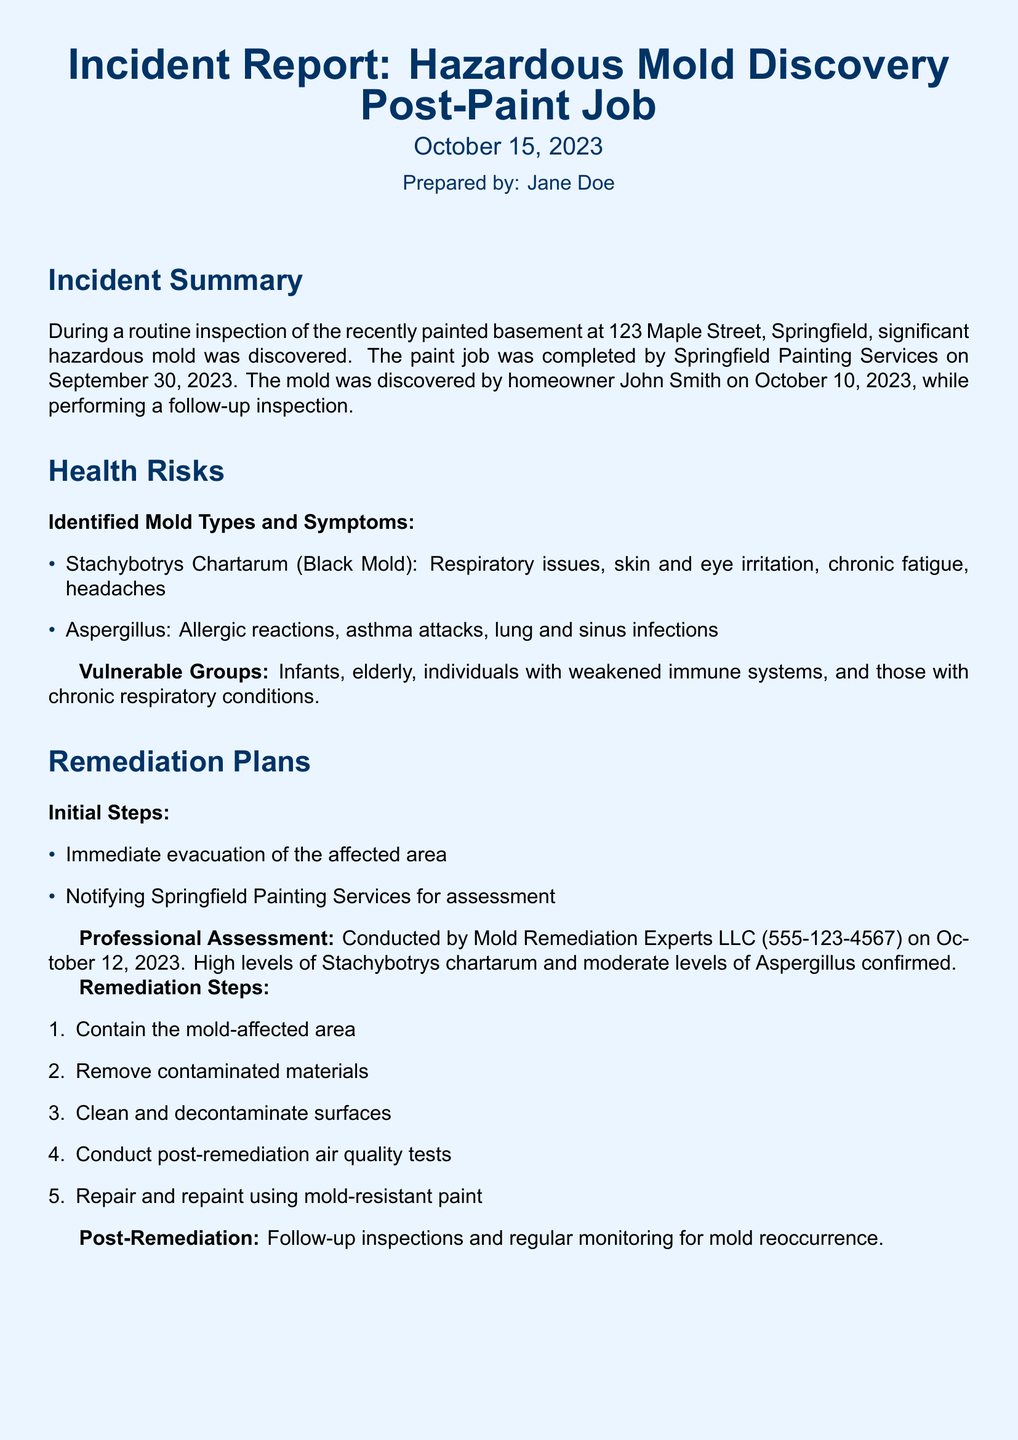What was discovered during the inspection? The report indicates that significant hazardous mold was discovered post-paint job.
Answer: hazardous mold Who prepared the incident report? The document lists Jane Doe as the preparer of the report.
Answer: Jane Doe When was the paint job completed? The completion date of the paint job is specified as September 30, 2023.
Answer: September 30, 2023 What are the symptoms of Stachybotrys chartarum? The report lists respiratory issues, skin and eye irritation, chronic fatigue, and headaches as symptoms.
Answer: respiratory issues, skin and eye irritation, chronic fatigue, headaches What is the phone number of Mold Remediation Experts LLC? The document provides the contact number for Mold Remediation Experts LLC as part of the professional assessment.
Answer: 555-123-4567 What immediate action was taken after mold discovery? The report states that immediate evacuation of the affected area was performed.
Answer: Immediate evacuation Which mold type is confirmed at high levels? The report confirms that high levels of Stachybotrys chartarum were found during the assessment.
Answer: Stachybotrys chartarum What maintenance tip is suggested regarding moisture-prone areas? The report recommends regularly inspecting moisture-prone areas as a maintenance tip.
Answer: Regularly inspect moisture-prone areas Who is the homeowner consulting after the mold discovery? The report mentions that John Smith plans to consult roofing and plumbing experts.
Answer: roofing and plumbing experts 